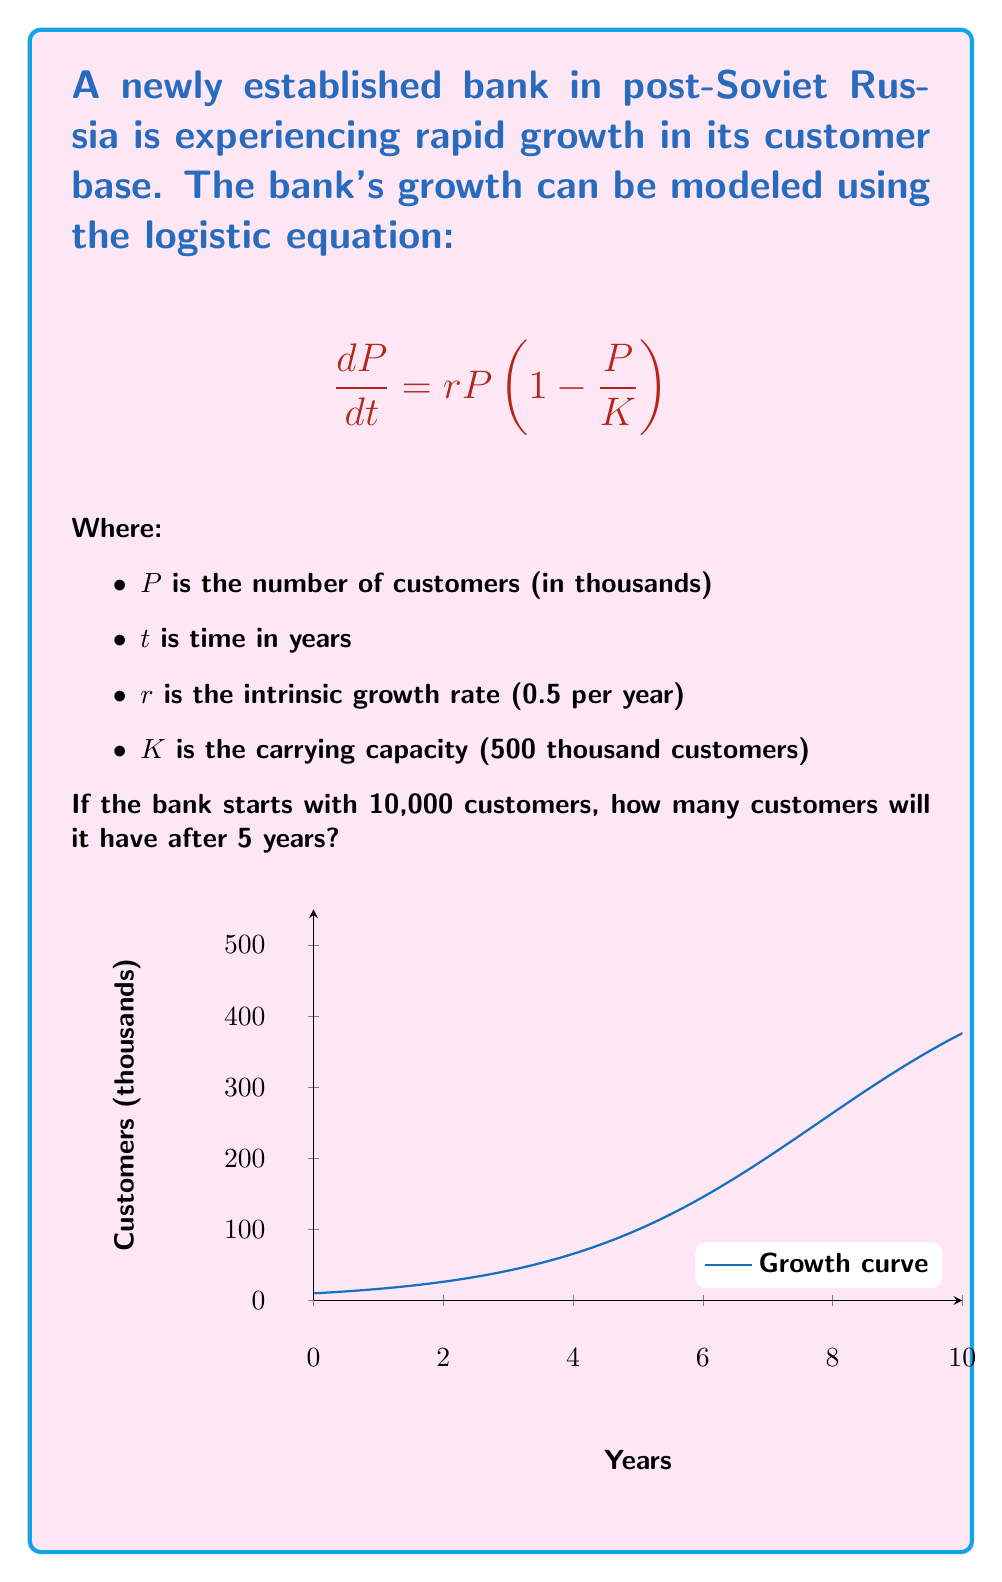Give your solution to this math problem. To solve this problem, we need to use the solution to the logistic equation:

$$P(t) = \frac{K}{1 + (\frac{K}{P_0} - 1)e^{-rt}}$$

Where $P_0$ is the initial population.

Step 1: Identify the given values:
$K = 500$ (thousand customers)
$r = 0.5$ (per year)
$P_0 = 10$ (thousand customers)
$t = 5$ (years)

Step 2: Substitute these values into the equation:

$$P(5) = \frac{500}{1 + (\frac{500}{10} - 1)e^{-0.5 \cdot 5}}$$

Step 3: Simplify:

$$P(5) = \frac{500}{1 + (49)e^{-2.5}}$$

Step 4: Calculate $e^{-2.5}$:

$$e^{-2.5} \approx 0.0821$$

Step 5: Substitute this value:

$$P(5) = \frac{500}{1 + 49 \cdot 0.0821} = \frac{500}{5.0229}$$

Step 6: Calculate the final result:

$$P(5) \approx 99.54$$ thousand customers
Answer: 99,540 customers 